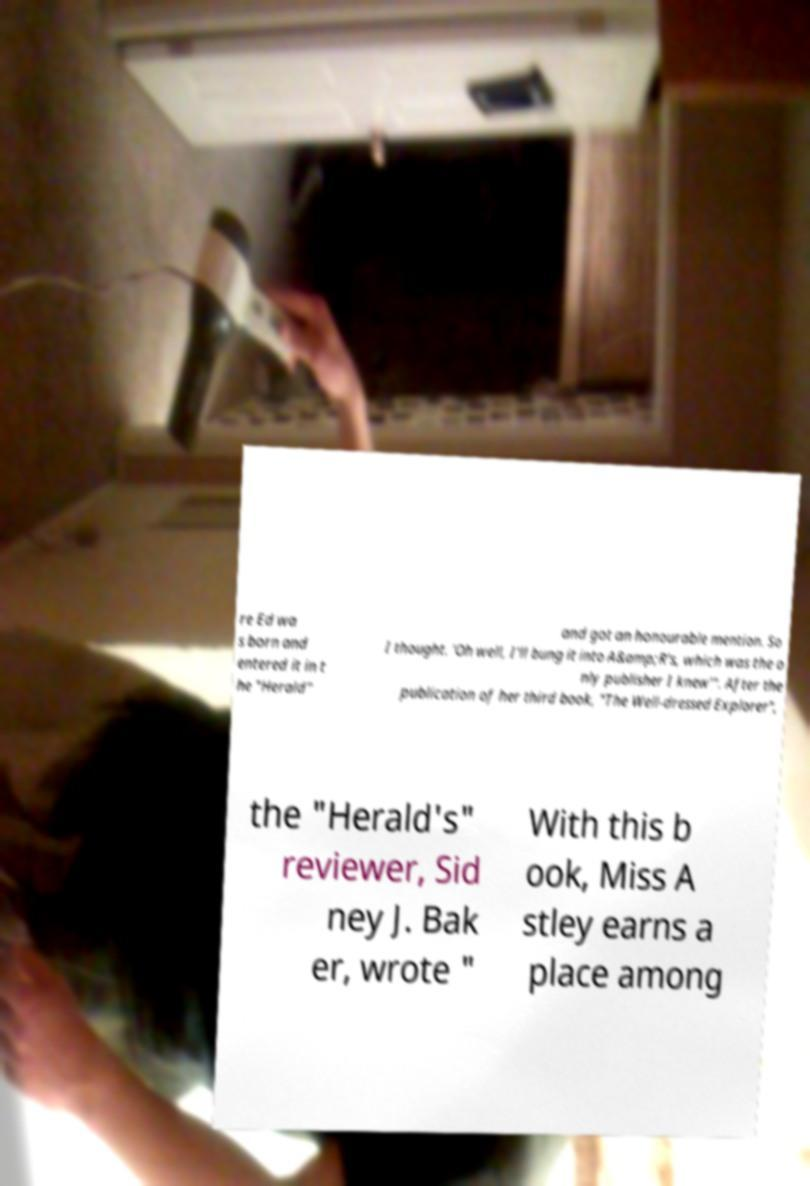I need the written content from this picture converted into text. Can you do that? re Ed wa s born and entered it in t he "Herald" and got an honourable mention. So I thought. 'Oh well, I'll bung it into A&amp;R's, which was the o nly publisher I knew'". After the publication of her third book, "The Well-dressed Explorer", the "Herald's" reviewer, Sid ney J. Bak er, wrote " With this b ook, Miss A stley earns a place among 